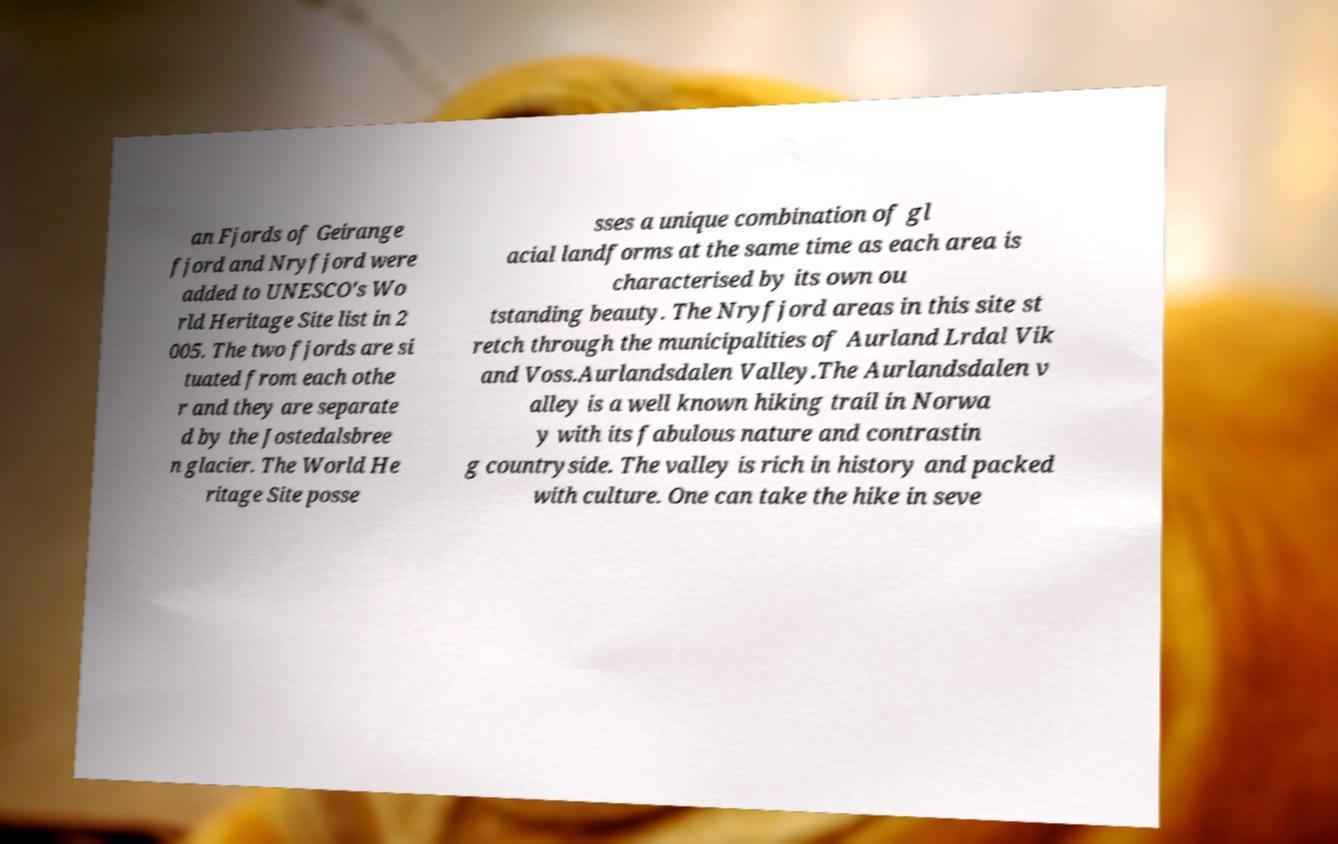Could you extract and type out the text from this image? an Fjords of Geirange fjord and Nryfjord were added to UNESCO's Wo rld Heritage Site list in 2 005. The two fjords are si tuated from each othe r and they are separate d by the Jostedalsbree n glacier. The World He ritage Site posse sses a unique combination of gl acial landforms at the same time as each area is characterised by its own ou tstanding beauty. The Nryfjord areas in this site st retch through the municipalities of Aurland Lrdal Vik and Voss.Aurlandsdalen Valley.The Aurlandsdalen v alley is a well known hiking trail in Norwa y with its fabulous nature and contrastin g countryside. The valley is rich in history and packed with culture. One can take the hike in seve 